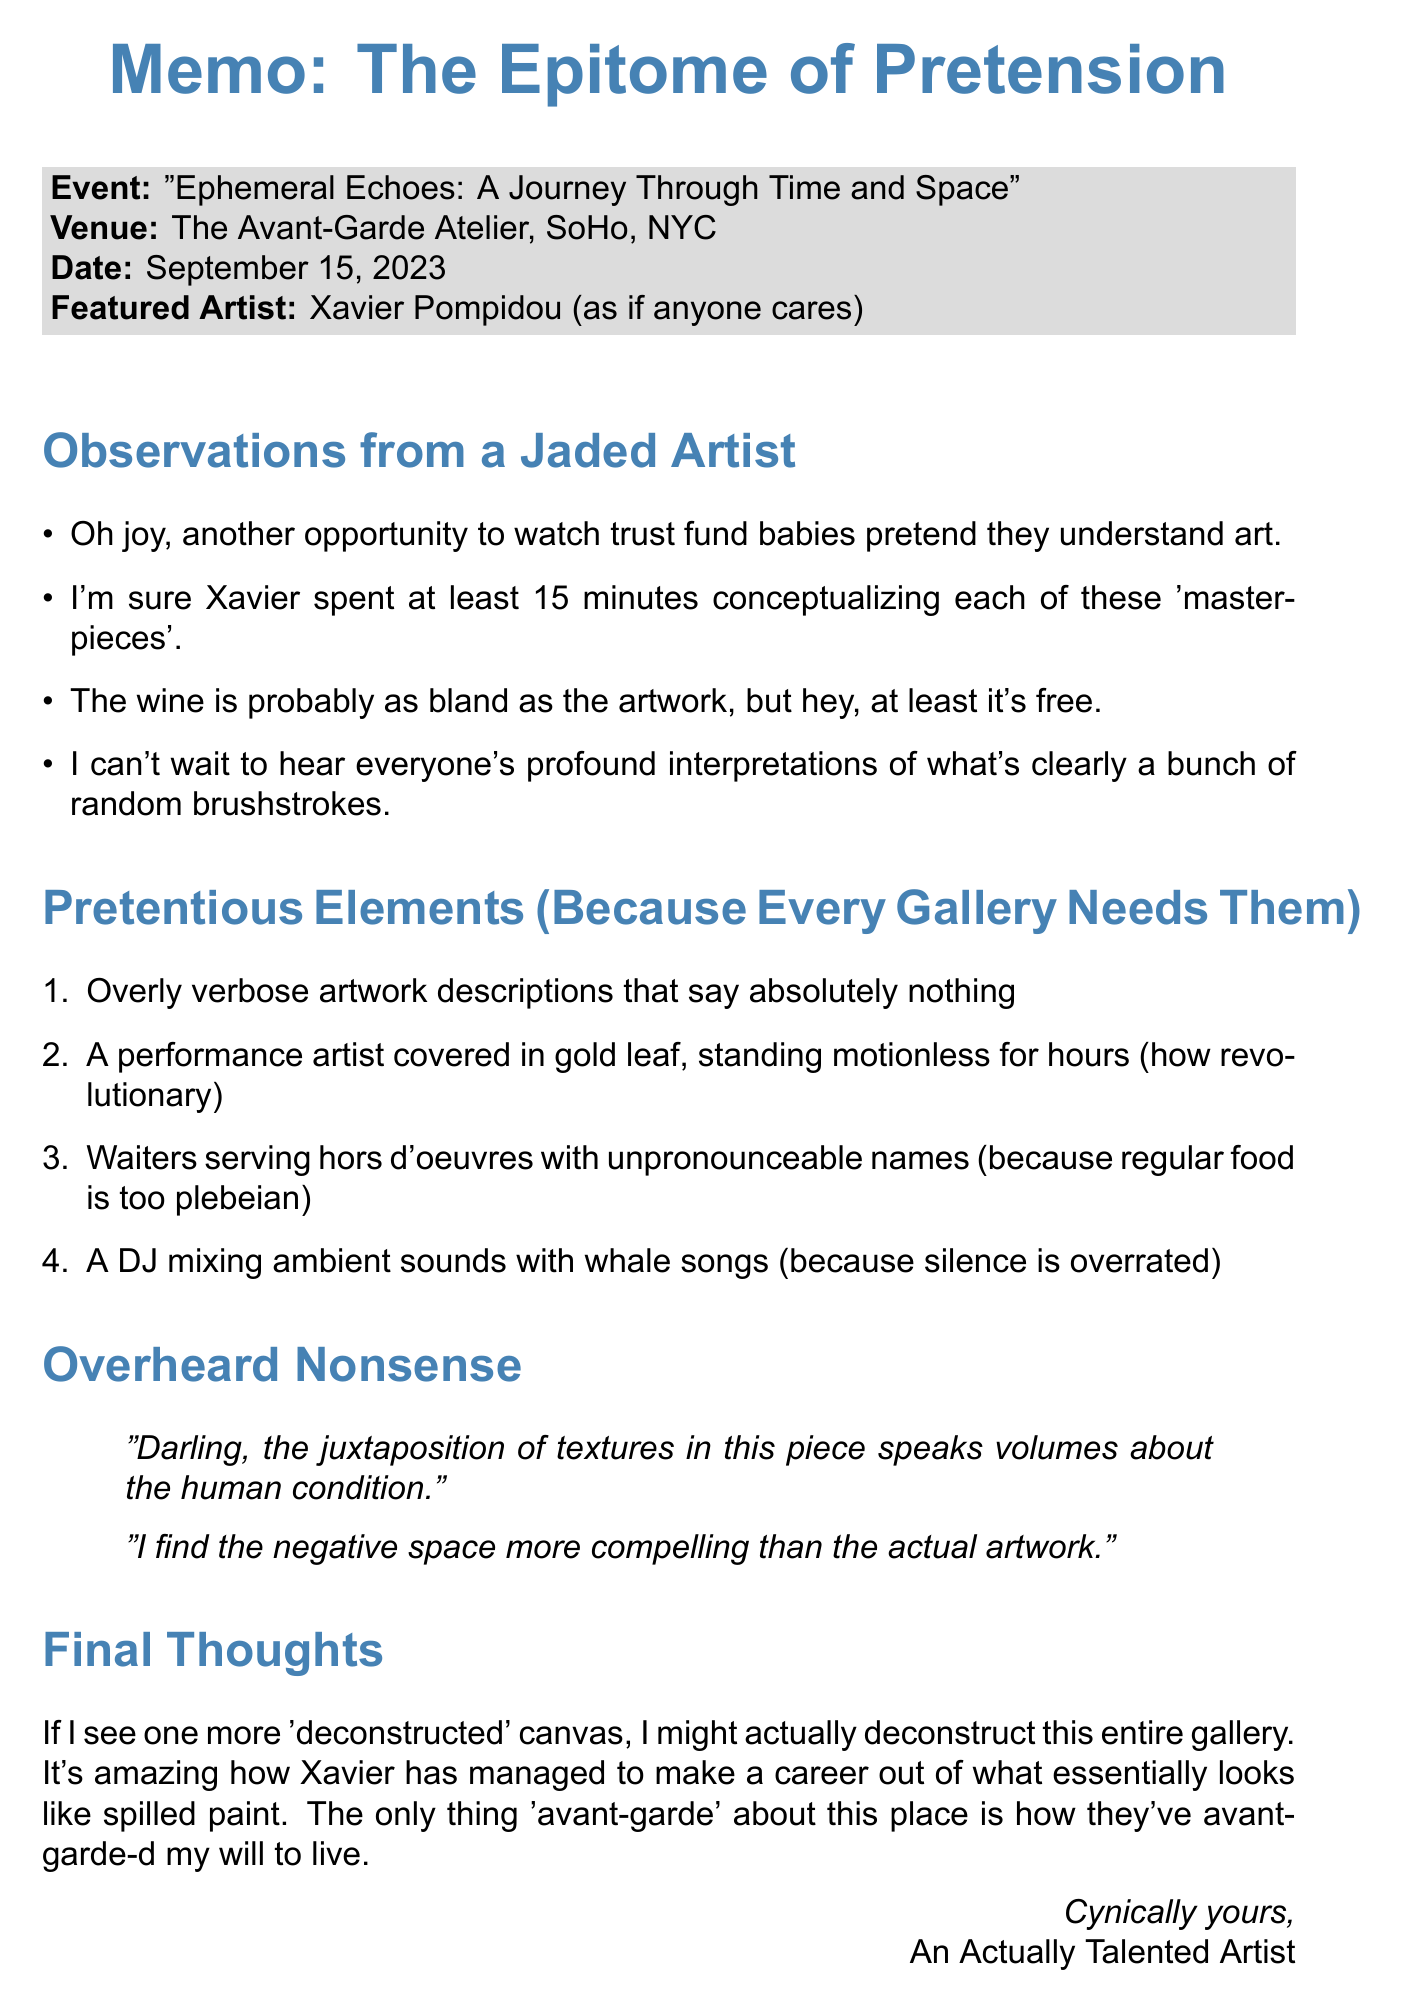What is the name of the gallery? The document specifies that the gallery is called "The Avant-Garde Atelier."
Answer: The Avant-Garde Atelier What is the title of the exhibition? The document details the exhibition as "Ephemeral Echoes: A Journey Through Time and Space."
Answer: Ephemeral Echoes: A Journey Through Time and Space When is the opening date? The opening date is explicitly stated in the document as September 15, 2023.
Answer: September 15, 2023 Who is the featured artist? The memo mentions that the featured artist is Xavier Pompidou.
Answer: Xavier Pompidou What is one of the pretentious elements mentioned? The document lists several pretentious elements, one of which is "Overly verbose artwork descriptions that say absolutely nothing."
Answer: Overly verbose artwork descriptions that say absolutely nothing What kind of reactions do people have at the gallery opening? The memo indicates that people are expected to nod thoughtfully, which suggests a certain type of reaction.
Answer: Nod thoughtfully What is the significance of the phrase "avant-garde" in the document? The document uses "avant-garde" ironically to critique the inflated egos and artwork prices in the gallery.
Answer: Critique of inflated egos and prices What does the author ultimately think about the exhibition? The overall sentiment conveyed by the author is one of cynicism, as expressed in the critique about a lack of originality.
Answer: Cynicism about lack of originality 